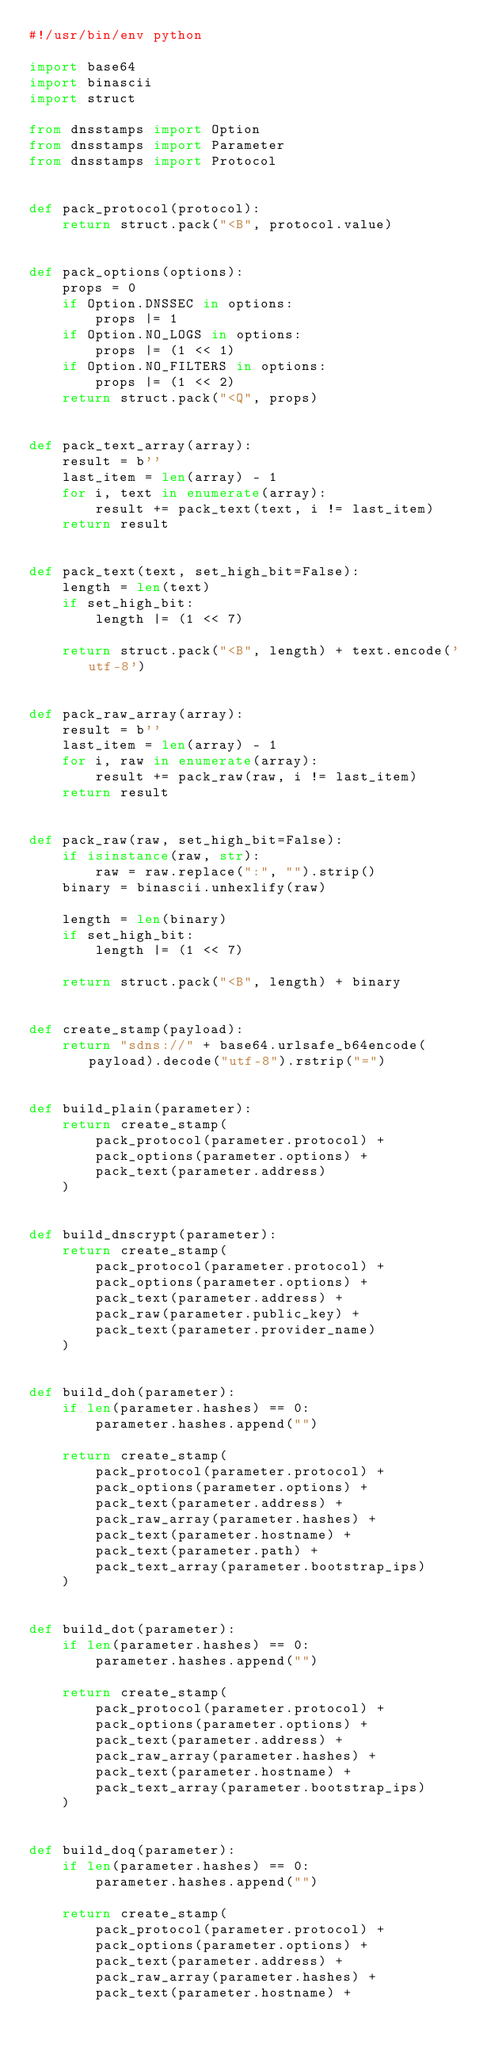Convert code to text. <code><loc_0><loc_0><loc_500><loc_500><_Python_>#!/usr/bin/env python

import base64
import binascii
import struct

from dnsstamps import Option
from dnsstamps import Parameter
from dnsstamps import Protocol


def pack_protocol(protocol):
    return struct.pack("<B", protocol.value)


def pack_options(options):
    props = 0
    if Option.DNSSEC in options:
        props |= 1
    if Option.NO_LOGS in options:
        props |= (1 << 1)
    if Option.NO_FILTERS in options:
        props |= (1 << 2)
    return struct.pack("<Q", props)


def pack_text_array(array):
    result = b''
    last_item = len(array) - 1
    for i, text in enumerate(array):
        result += pack_text(text, i != last_item)
    return result


def pack_text(text, set_high_bit=False):
    length = len(text)
    if set_high_bit:
        length |= (1 << 7)

    return struct.pack("<B", length) + text.encode('utf-8')


def pack_raw_array(array):
    result = b''
    last_item = len(array) - 1
    for i, raw in enumerate(array):
        result += pack_raw(raw, i != last_item)
    return result


def pack_raw(raw, set_high_bit=False):
    if isinstance(raw, str):
        raw = raw.replace(":", "").strip()
    binary = binascii.unhexlify(raw)

    length = len(binary)
    if set_high_bit:
        length |= (1 << 7)

    return struct.pack("<B", length) + binary


def create_stamp(payload):
    return "sdns://" + base64.urlsafe_b64encode(payload).decode("utf-8").rstrip("=")


def build_plain(parameter):
    return create_stamp(
        pack_protocol(parameter.protocol) +
        pack_options(parameter.options) +
        pack_text(parameter.address)
    )


def build_dnscrypt(parameter):
    return create_stamp(
        pack_protocol(parameter.protocol) +
        pack_options(parameter.options) +
        pack_text(parameter.address) +
        pack_raw(parameter.public_key) +
        pack_text(parameter.provider_name)
    )


def build_doh(parameter):
    if len(parameter.hashes) == 0:
        parameter.hashes.append("")

    return create_stamp(
        pack_protocol(parameter.protocol) +
        pack_options(parameter.options) +
        pack_text(parameter.address) +
        pack_raw_array(parameter.hashes) +
        pack_text(parameter.hostname) +
        pack_text(parameter.path) +
        pack_text_array(parameter.bootstrap_ips)
    )


def build_dot(parameter):
    if len(parameter.hashes) == 0:
        parameter.hashes.append("")

    return create_stamp(
        pack_protocol(parameter.protocol) +
        pack_options(parameter.options) +
        pack_text(parameter.address) +
        pack_raw_array(parameter.hashes) +
        pack_text(parameter.hostname) +
        pack_text_array(parameter.bootstrap_ips)
    )


def build_doq(parameter):
    if len(parameter.hashes) == 0:
        parameter.hashes.append("")

    return create_stamp(
        pack_protocol(parameter.protocol) +
        pack_options(parameter.options) +
        pack_text(parameter.address) +
        pack_raw_array(parameter.hashes) +
        pack_text(parameter.hostname) +</code> 